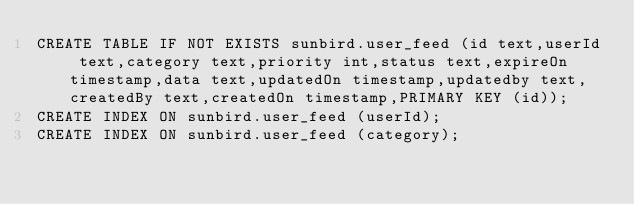Convert code to text. <code><loc_0><loc_0><loc_500><loc_500><_SQL_>CREATE TABLE IF NOT EXISTS sunbird.user_feed (id text,userId text,category text,priority int,status text,expireOn timestamp,data text,updatedOn timestamp,updatedby text,createdBy text,createdOn timestamp,PRIMARY KEY (id));
CREATE INDEX ON sunbird.user_feed (userId);
CREATE INDEX ON sunbird.user_feed (category);

</code> 